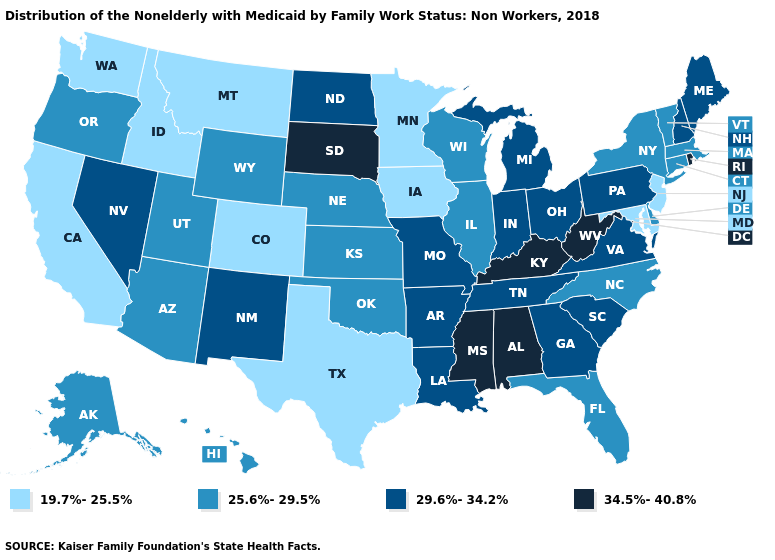Name the states that have a value in the range 29.6%-34.2%?
Write a very short answer. Arkansas, Georgia, Indiana, Louisiana, Maine, Michigan, Missouri, Nevada, New Hampshire, New Mexico, North Dakota, Ohio, Pennsylvania, South Carolina, Tennessee, Virginia. What is the highest value in the USA?
Keep it brief. 34.5%-40.8%. What is the highest value in the USA?
Quick response, please. 34.5%-40.8%. Is the legend a continuous bar?
Quick response, please. No. Which states have the highest value in the USA?
Write a very short answer. Alabama, Kentucky, Mississippi, Rhode Island, South Dakota, West Virginia. What is the value of Wisconsin?
Write a very short answer. 25.6%-29.5%. Does Michigan have the lowest value in the MidWest?
Keep it brief. No. Does New Mexico have a lower value than Georgia?
Keep it brief. No. Which states hav the highest value in the South?
Answer briefly. Alabama, Kentucky, Mississippi, West Virginia. Does North Dakota have a lower value than South Dakota?
Give a very brief answer. Yes. Name the states that have a value in the range 19.7%-25.5%?
Short answer required. California, Colorado, Idaho, Iowa, Maryland, Minnesota, Montana, New Jersey, Texas, Washington. Which states have the lowest value in the USA?
Quick response, please. California, Colorado, Idaho, Iowa, Maryland, Minnesota, Montana, New Jersey, Texas, Washington. Does California have the lowest value in the USA?
Keep it brief. Yes. What is the value of Florida?
Concise answer only. 25.6%-29.5%. Name the states that have a value in the range 29.6%-34.2%?
Give a very brief answer. Arkansas, Georgia, Indiana, Louisiana, Maine, Michigan, Missouri, Nevada, New Hampshire, New Mexico, North Dakota, Ohio, Pennsylvania, South Carolina, Tennessee, Virginia. 